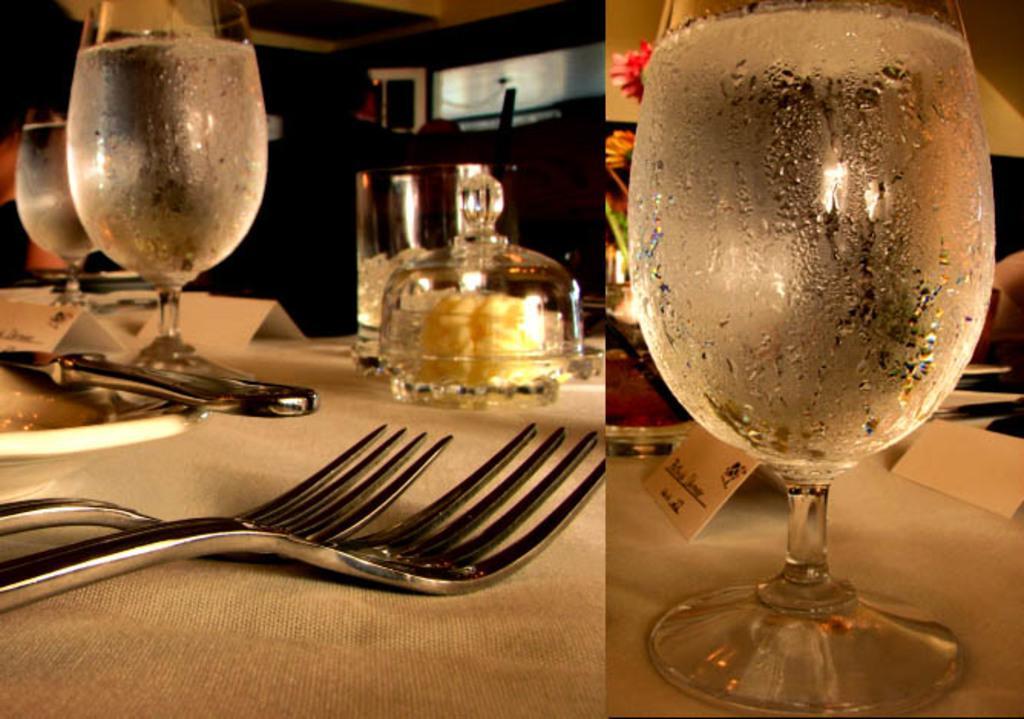Describe this image in one or two sentences. This looks like a collage picture. This is a table covered with a cloth. I can see the wine glasses with liquid, forks, plate, name cards, flowers and few other objects on it. In the background, I can see a person standing. 